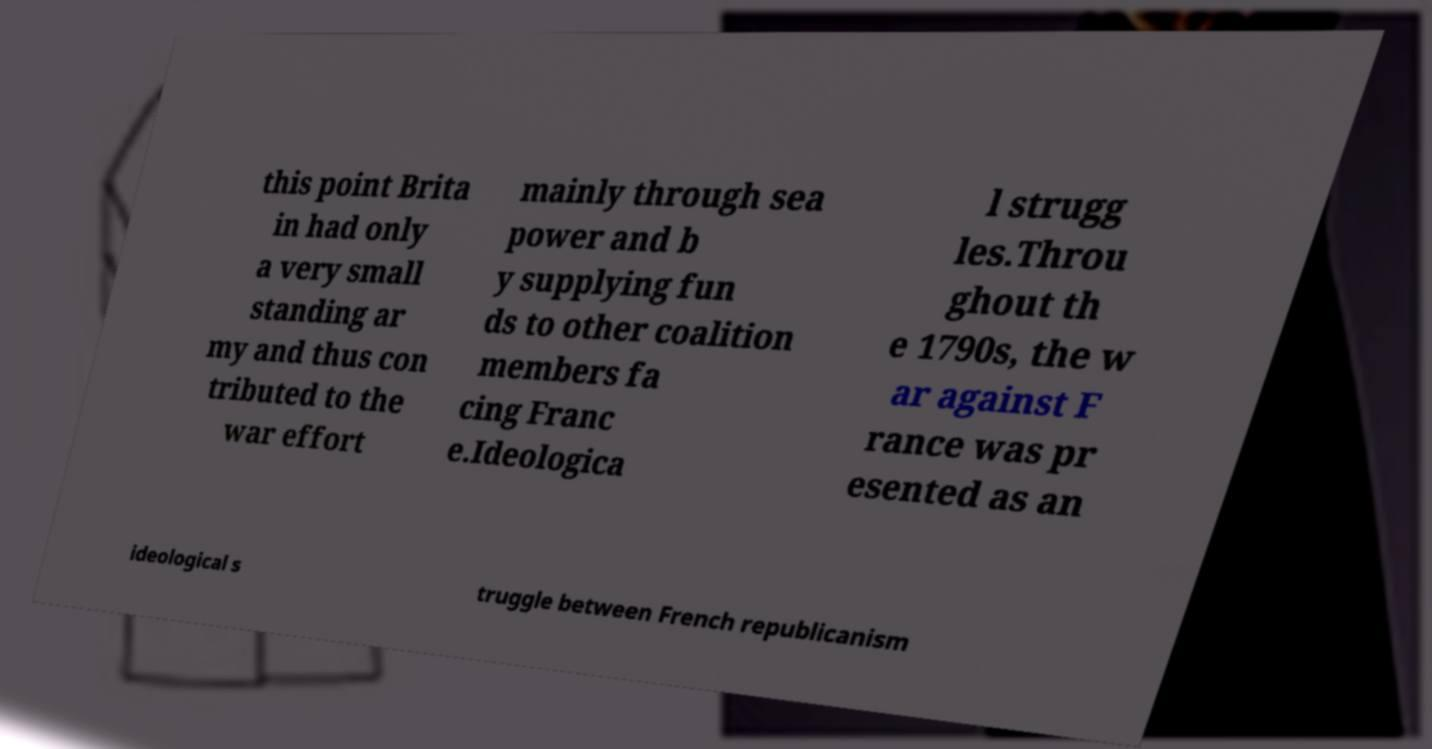For documentation purposes, I need the text within this image transcribed. Could you provide that? this point Brita in had only a very small standing ar my and thus con tributed to the war effort mainly through sea power and b y supplying fun ds to other coalition members fa cing Franc e.Ideologica l strugg les.Throu ghout th e 1790s, the w ar against F rance was pr esented as an ideological s truggle between French republicanism 